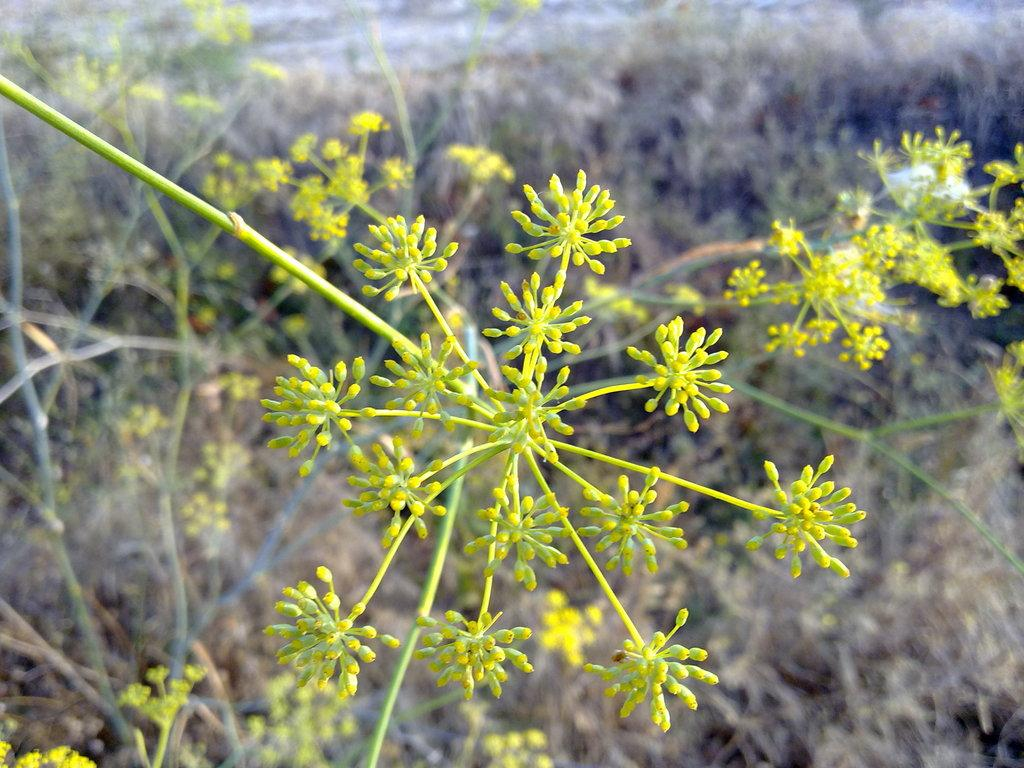What type of plants can be seen in the image? There are plants with flowers in the image. Can you describe the location of the plants in the image? The plants are on the land in the background of the image. What color are the eyes of the vest in the image? There is no vest or eyes present in the image; it features plants with flowers. 